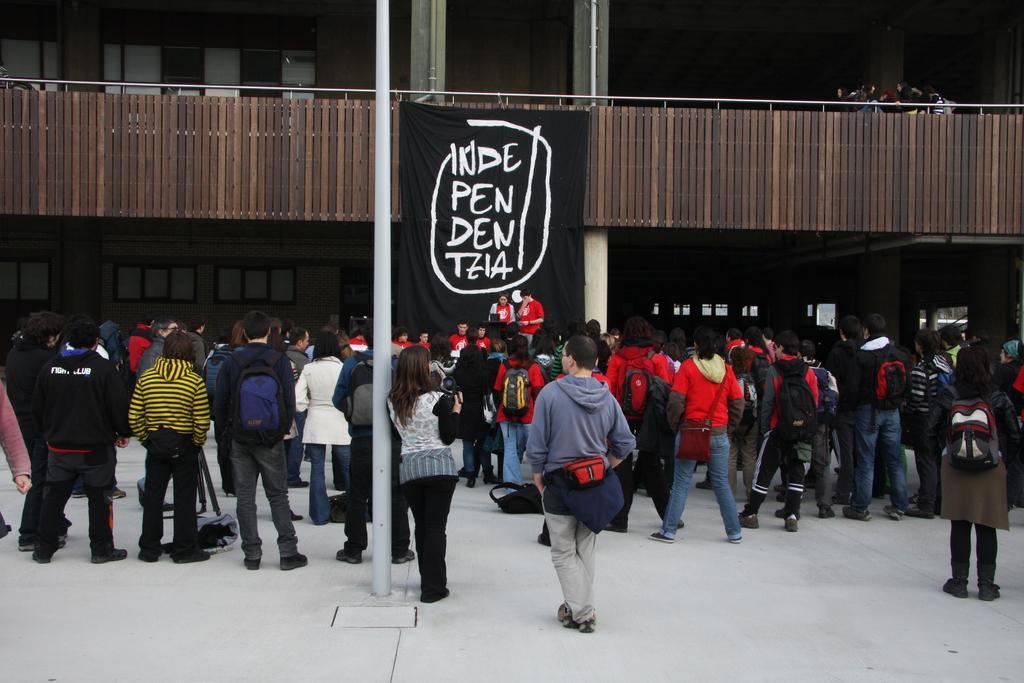Could you give a brief overview of what you see in this image? In this image, we can see some people standing, in the middle we can see a black cloth with some text on it. We can see the wooden railing. 